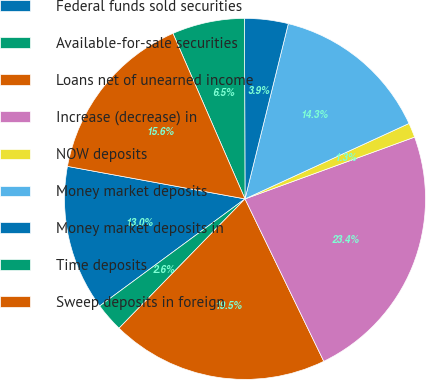Convert chart. <chart><loc_0><loc_0><loc_500><loc_500><pie_chart><fcel>Federal funds sold securities<fcel>Available-for-sale securities<fcel>Loans net of unearned income<fcel>Increase (decrease) in<fcel>NOW deposits<fcel>Money market deposits<fcel>Money market deposits in<fcel>Time deposits<fcel>Sweep deposits in foreign<nl><fcel>12.99%<fcel>2.6%<fcel>19.48%<fcel>23.37%<fcel>1.3%<fcel>14.28%<fcel>3.9%<fcel>6.49%<fcel>15.58%<nl></chart> 